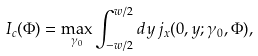Convert formula to latex. <formula><loc_0><loc_0><loc_500><loc_500>I _ { c } ( \Phi ) = \max _ { \gamma _ { 0 } } \int _ { - w / 2 } ^ { w / 2 } d y \, j _ { x } ( 0 , y ; \gamma _ { 0 } , \Phi ) ,</formula> 